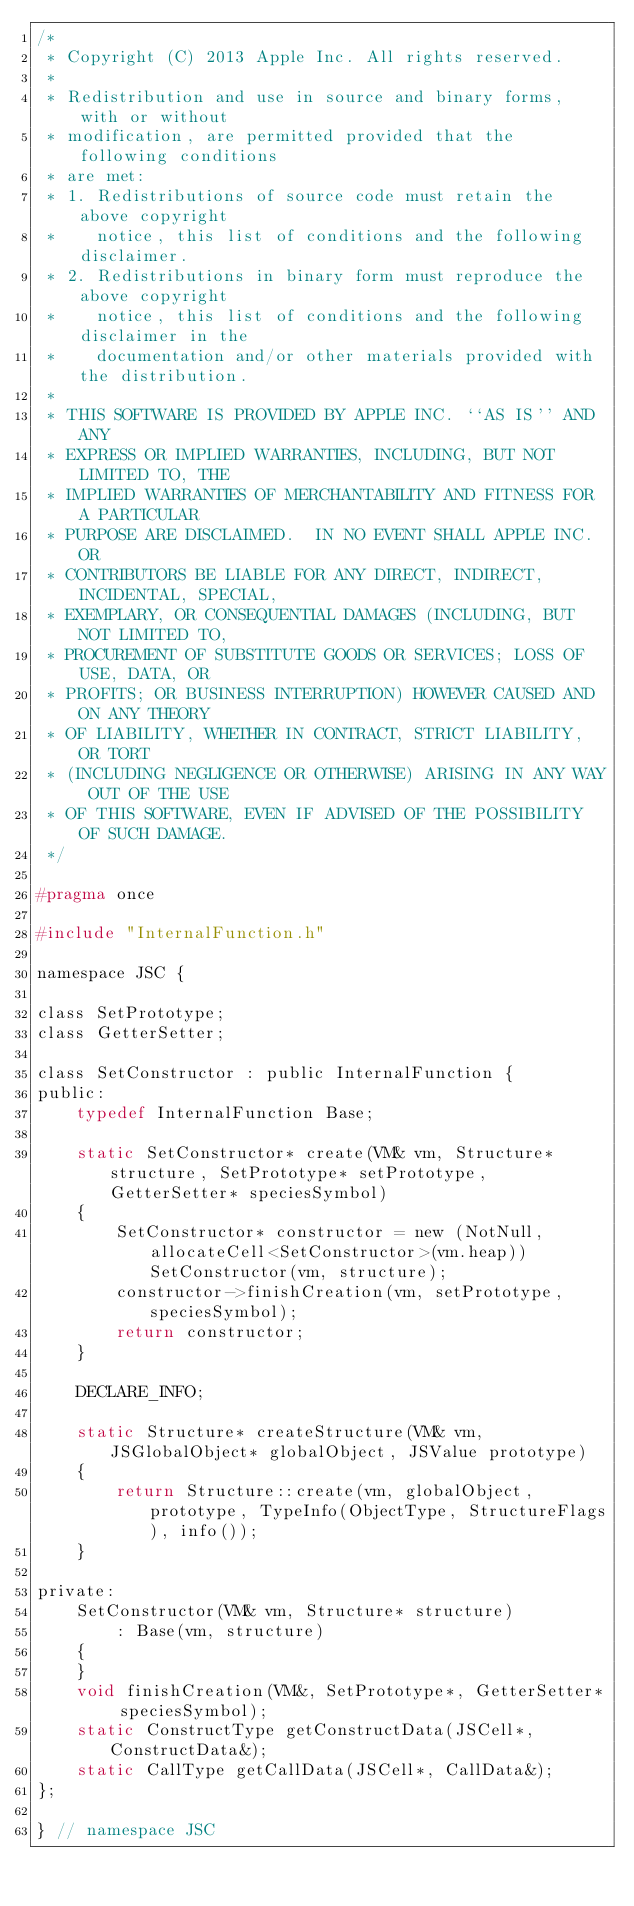<code> <loc_0><loc_0><loc_500><loc_500><_C_>/*
 * Copyright (C) 2013 Apple Inc. All rights reserved.
 *
 * Redistribution and use in source and binary forms, with or without
 * modification, are permitted provided that the following conditions
 * are met:
 * 1. Redistributions of source code must retain the above copyright
 *    notice, this list of conditions and the following disclaimer.
 * 2. Redistributions in binary form must reproduce the above copyright
 *    notice, this list of conditions and the following disclaimer in the
 *    documentation and/or other materials provided with the distribution.
 *
 * THIS SOFTWARE IS PROVIDED BY APPLE INC. ``AS IS'' AND ANY
 * EXPRESS OR IMPLIED WARRANTIES, INCLUDING, BUT NOT LIMITED TO, THE
 * IMPLIED WARRANTIES OF MERCHANTABILITY AND FITNESS FOR A PARTICULAR
 * PURPOSE ARE DISCLAIMED.  IN NO EVENT SHALL APPLE INC. OR
 * CONTRIBUTORS BE LIABLE FOR ANY DIRECT, INDIRECT, INCIDENTAL, SPECIAL,
 * EXEMPLARY, OR CONSEQUENTIAL DAMAGES (INCLUDING, BUT NOT LIMITED TO,
 * PROCUREMENT OF SUBSTITUTE GOODS OR SERVICES; LOSS OF USE, DATA, OR
 * PROFITS; OR BUSINESS INTERRUPTION) HOWEVER CAUSED AND ON ANY THEORY
 * OF LIABILITY, WHETHER IN CONTRACT, STRICT LIABILITY, OR TORT
 * (INCLUDING NEGLIGENCE OR OTHERWISE) ARISING IN ANY WAY OUT OF THE USE
 * OF THIS SOFTWARE, EVEN IF ADVISED OF THE POSSIBILITY OF SUCH DAMAGE.
 */

#pragma once

#include "InternalFunction.h"

namespace JSC {

class SetPrototype;
class GetterSetter;

class SetConstructor : public InternalFunction {
public:
    typedef InternalFunction Base;

    static SetConstructor* create(VM& vm, Structure* structure, SetPrototype* setPrototype, GetterSetter* speciesSymbol)
    {
        SetConstructor* constructor = new (NotNull, allocateCell<SetConstructor>(vm.heap)) SetConstructor(vm, structure);
        constructor->finishCreation(vm, setPrototype, speciesSymbol);
        return constructor;
    }

    DECLARE_INFO;

    static Structure* createStructure(VM& vm, JSGlobalObject* globalObject, JSValue prototype)
    {
        return Structure::create(vm, globalObject, prototype, TypeInfo(ObjectType, StructureFlags), info());
    }

private:
    SetConstructor(VM& vm, Structure* structure)
        : Base(vm, structure)
    {
    }
    void finishCreation(VM&, SetPrototype*, GetterSetter* speciesSymbol);
    static ConstructType getConstructData(JSCell*, ConstructData&);
    static CallType getCallData(JSCell*, CallData&);
};

} // namespace JSC
</code> 